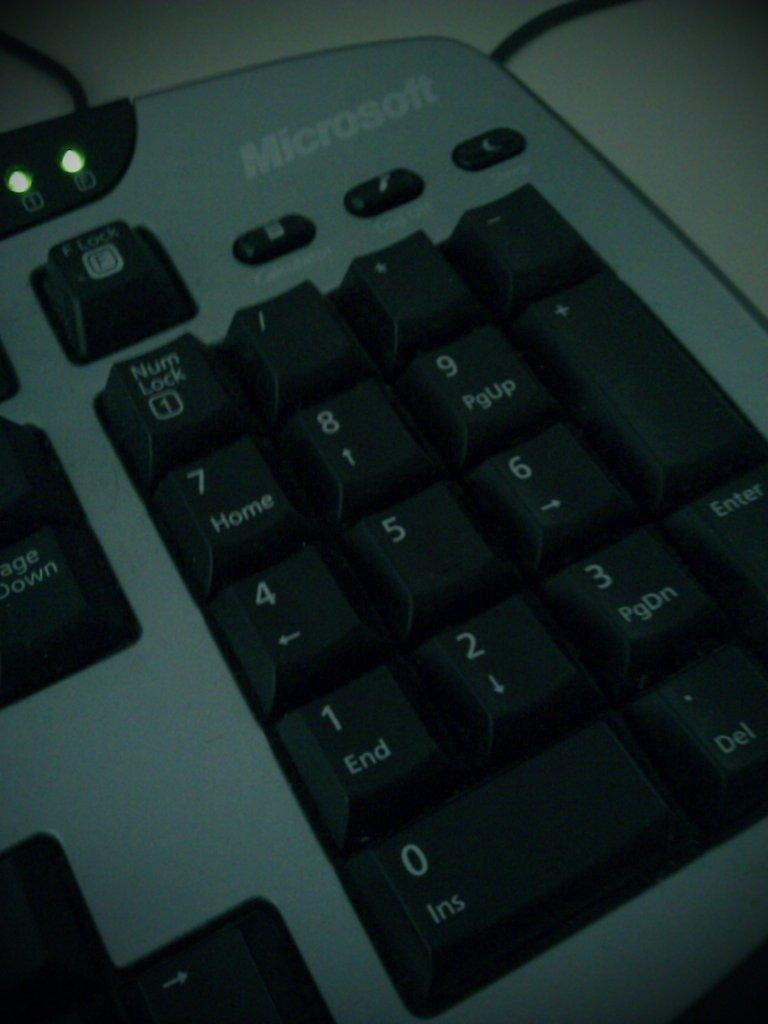<image>
Write a terse but informative summary of the picture. A close up of the numbers on a microsoft keyboard. 